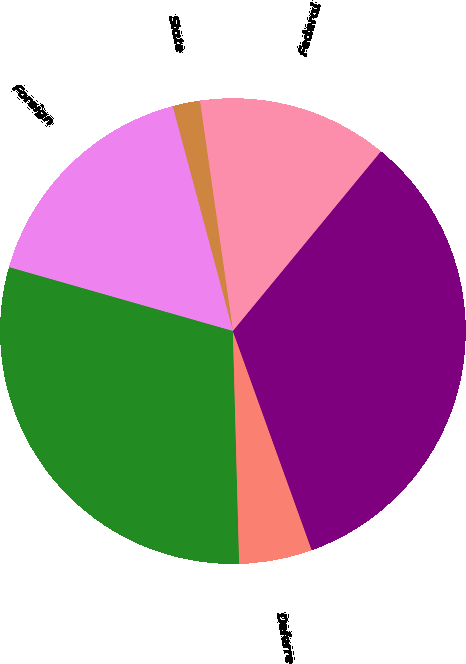Convert chart to OTSL. <chart><loc_0><loc_0><loc_500><loc_500><pie_chart><fcel>Federal<fcel>State<fcel>Foreign<fcel>Total current<fcel>Deferred<fcel>Total provision<nl><fcel>13.24%<fcel>1.9%<fcel>16.41%<fcel>29.85%<fcel>5.07%<fcel>33.53%<nl></chart> 